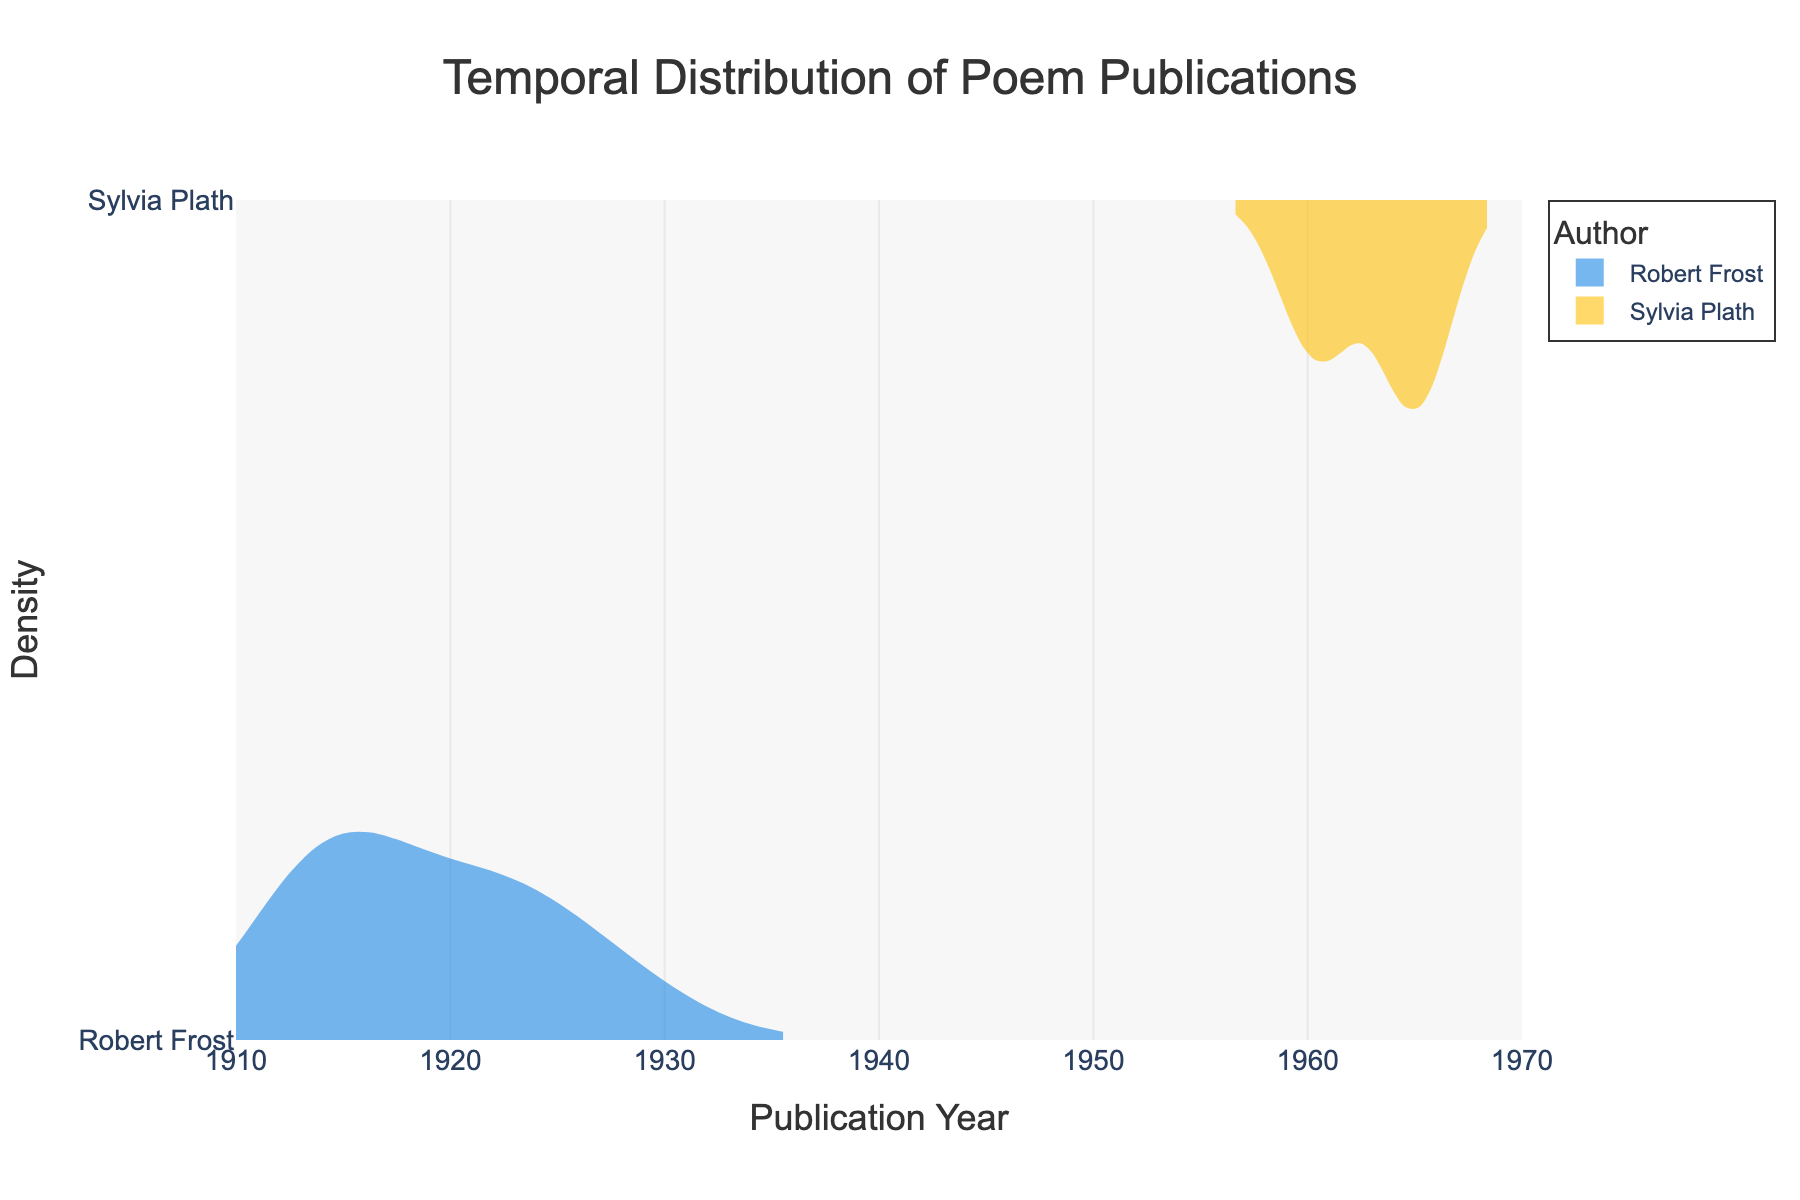What are the colors used for the density plots of Robert Frost and Sylvia Plath? The color used for Robert Frost's density plot is blue, and the color used for Sylvia Plath's density plot is yellow. This is evident from the legend and the filled areas' appearance in the figure.
Answer: Blue for Frost, Yellow for Plath What is the title of the figure? The title of the figure is prominently displayed at the top of the plot and reads "Temporal Distribution of Poem Publications".
Answer: Temporal Distribution of Poem Publications Over which range of years does the x-axis span? The x-axis range can be observed from the axis labels, showing it spans from the year 1910 to 1970, inclusive.
Answer: 1910 to 1970 Which author has a broader temporal distribution of publications? Observing the density plots shown on the figure, Robert Frost’s publications span from approximately 1910 to 1930, while Sylvia Plath’s span from 1960 to 1970. Therefore, Frost has a broader temporal distribution.
Answer: Robert Frost From the appearances of the density plots, in which decade was the peak publication period for Robert Frost? The peak of the density plot for Robert Frost appears to be in the 1920s. This is where the highest concentration of poem publications can be observed.
Answer: 1920s How does the density of poems published by Sylvia Plath in the 1960s compare to that of Robert Frost in the 1920s? The density plot for Sylvia Plath shows a high concentration in the 1960s, similar in prominence to Robert Frost’s high concentration in the 1920s. Both authors share a peak decade of publication.
Answer: Similar peak density Which author has poems published in the 1950s based on the density plots? Observing the density plots, there is no evident publication density for either author in the 1950s, indicating that neither Robert Frost nor Sylvia Plath has poems published during that decade.
Answer: Neither Based on the density plots, is there an overlap in the publication periods of Robert Frost and Sylvia Plath? Examining the x-axis and density plots, Robert Frost’s publications are around the 1910s to 1930, and Sylvia Plath's are in the 1960s. Thus, there is no overlap between their publication periods.
Answer: No overlap Which author has more poems published in the 1960s according to the density plot? The yellow density plot for Sylvia Plath shows significant publication activity in the 1960s, whereas there is no corresponding peak for Robert Frost. Thus, Sylvia Plath has more poems published in the 1960s.
Answer: Sylvia Plath 